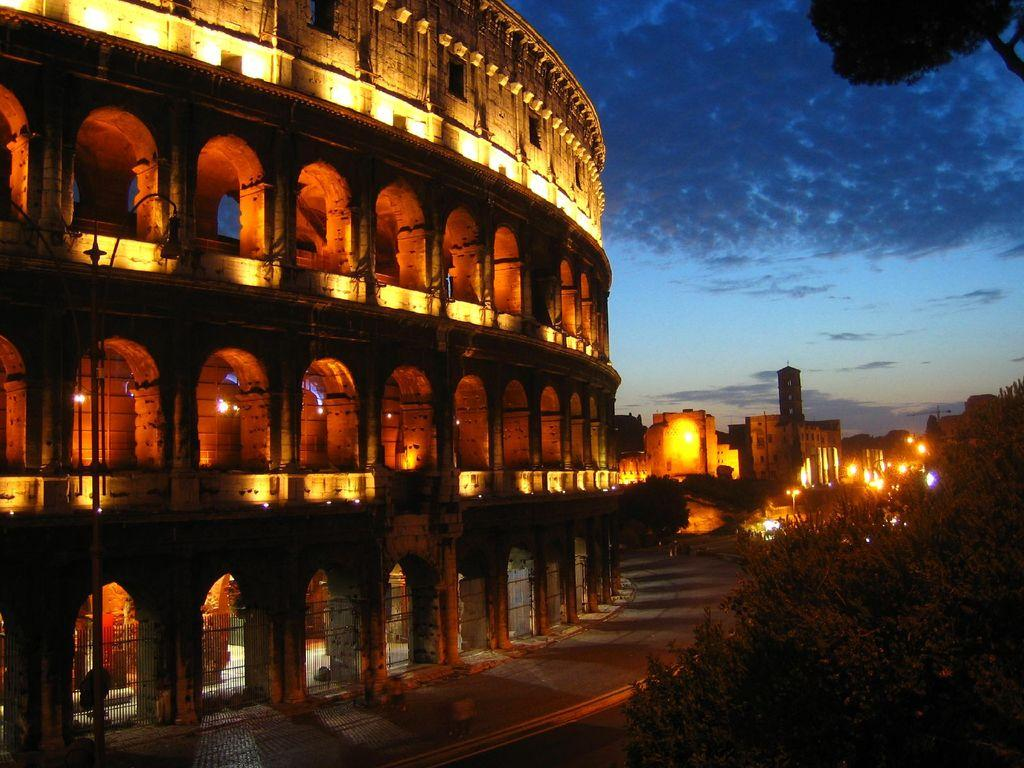What type of structures can be seen in the image? There are buildings in the image. What type of vegetation is present in the image? There are trees in the image. What type of lighting is present in the image? There are street lights in the image. What type of barrier is present in the image? There is a fence in the image. What else can be seen in the image besides the mentioned elements? There are other objects in the image. What is visible in the background of the image? The sky is visible in the background of the image. Can you tell me how many animals are visible in the zoo in the image? There is no zoo present in the image, so it is not possible to determine the number of animals. What type of watch is the person wearing in the image? There is no person wearing a watch in the image. 